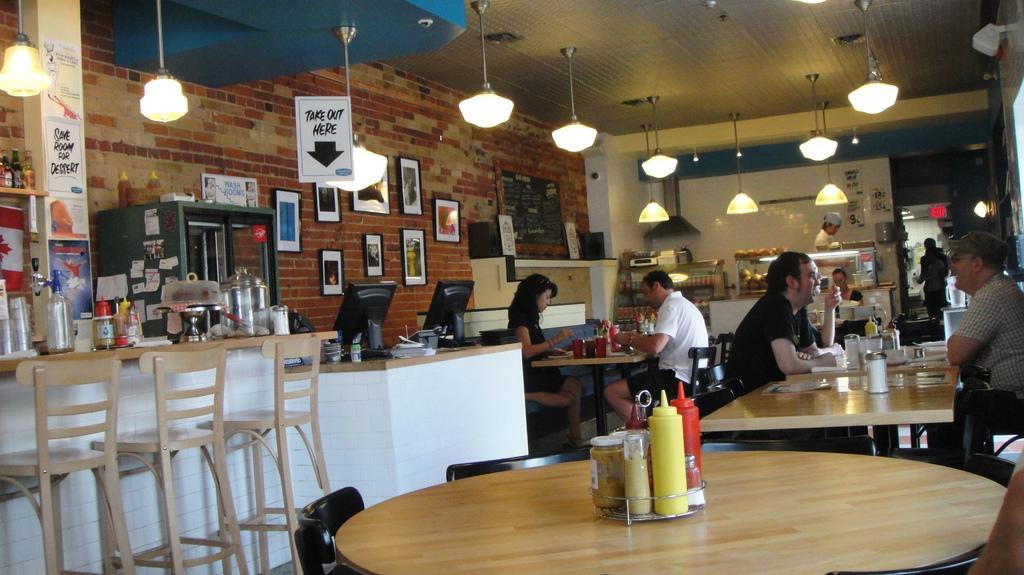How would you summarize this image in a sentence or two? In this image I can see few people are sitting on chairs. I can also see number of tables and few more chairs. Here on this wall I can see few frames. 